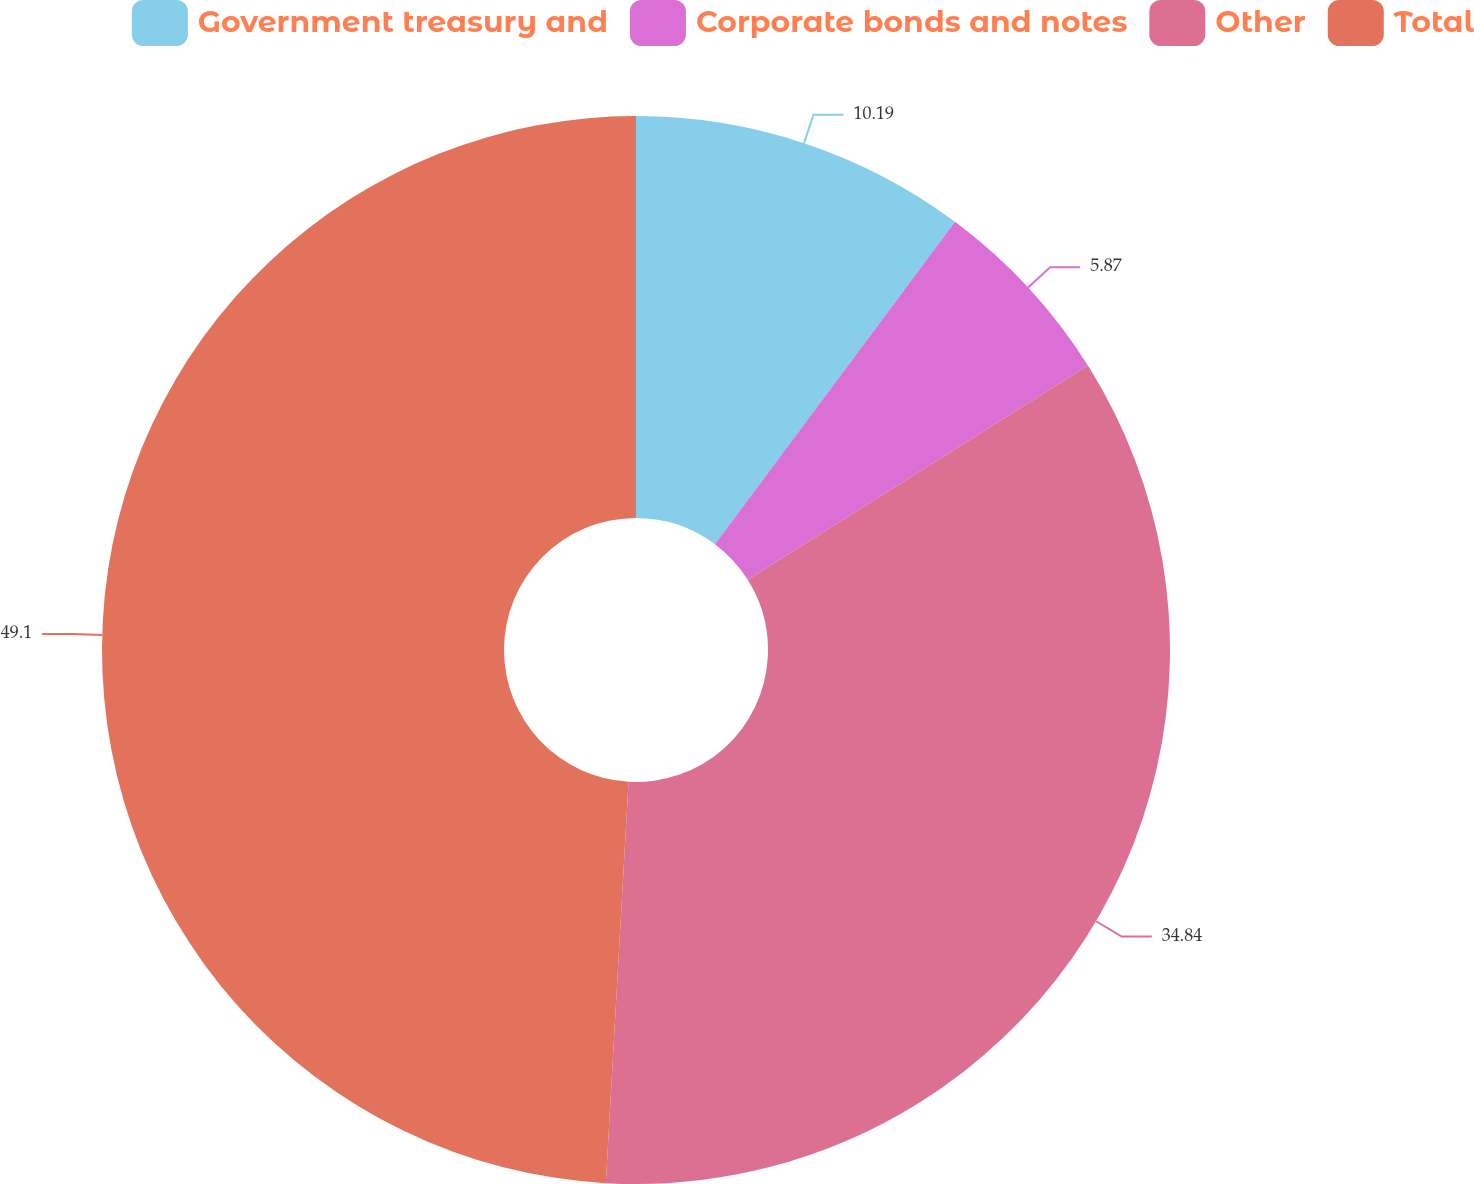Convert chart. <chart><loc_0><loc_0><loc_500><loc_500><pie_chart><fcel>Government treasury and<fcel>Corporate bonds and notes<fcel>Other<fcel>Total<nl><fcel>10.19%<fcel>5.87%<fcel>34.84%<fcel>49.1%<nl></chart> 